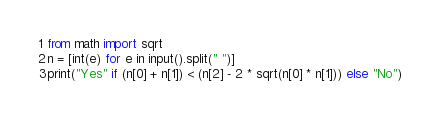Convert code to text. <code><loc_0><loc_0><loc_500><loc_500><_Python_>from math import sqrt
n = [int(e) for e in input().split(" ")]
print("Yes" if (n[0] + n[1]) < (n[2] - 2 * sqrt(n[0] * n[1])) else "No")</code> 